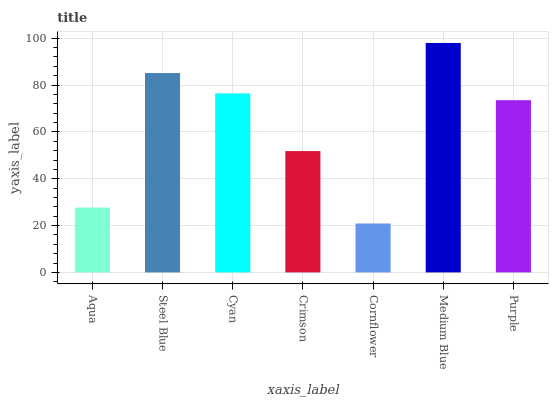Is Cornflower the minimum?
Answer yes or no. Yes. Is Medium Blue the maximum?
Answer yes or no. Yes. Is Steel Blue the minimum?
Answer yes or no. No. Is Steel Blue the maximum?
Answer yes or no. No. Is Steel Blue greater than Aqua?
Answer yes or no. Yes. Is Aqua less than Steel Blue?
Answer yes or no. Yes. Is Aqua greater than Steel Blue?
Answer yes or no. No. Is Steel Blue less than Aqua?
Answer yes or no. No. Is Purple the high median?
Answer yes or no. Yes. Is Purple the low median?
Answer yes or no. Yes. Is Steel Blue the high median?
Answer yes or no. No. Is Cornflower the low median?
Answer yes or no. No. 